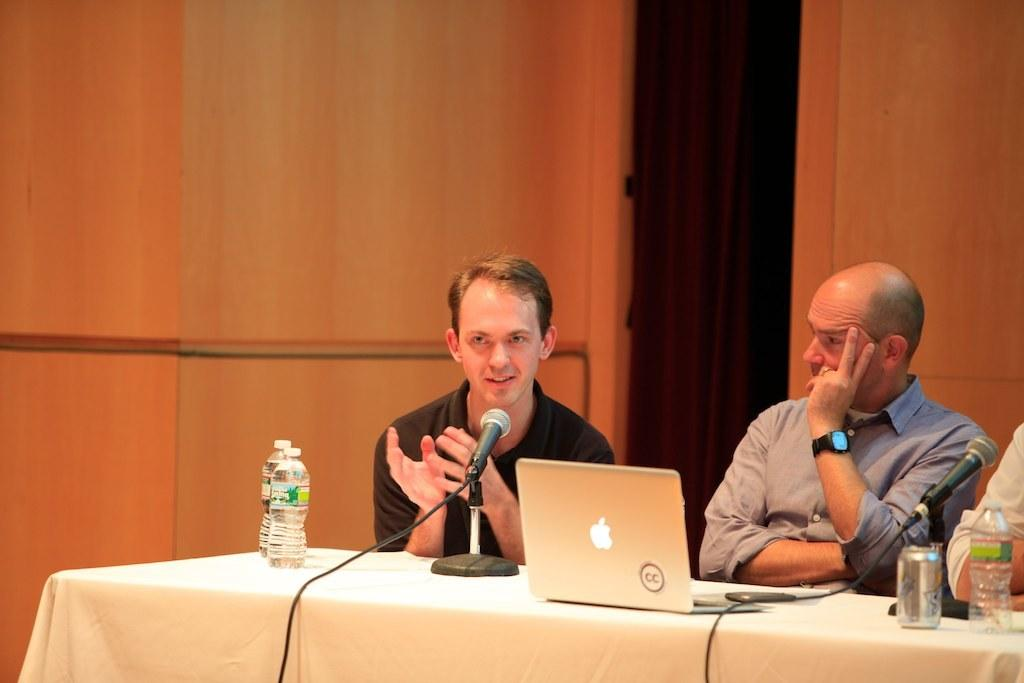What are the people in the image doing? The people in the image are sitting on chairs. What can be seen on the table in the image? There is a laptop and water bottles on the table in the image. What objects are related to communication in the image? There are microphones in the image. What type of beverage container is present in the image? There is a drink can in the image. What type of dog is sitting next to the people in the image? There is no dog present in the image. What decision is being made by the people in the image? The image does not provide any information about a decision being made. What type of yarn is being used by the people in the image? There is no yarn present in the image. 